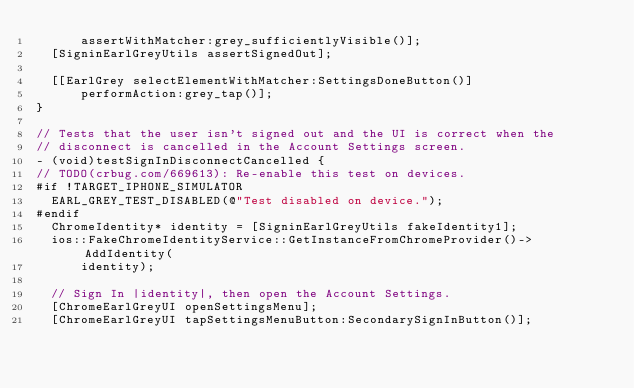Convert code to text. <code><loc_0><loc_0><loc_500><loc_500><_ObjectiveC_>      assertWithMatcher:grey_sufficientlyVisible()];
  [SigninEarlGreyUtils assertSignedOut];

  [[EarlGrey selectElementWithMatcher:SettingsDoneButton()]
      performAction:grey_tap()];
}

// Tests that the user isn't signed out and the UI is correct when the
// disconnect is cancelled in the Account Settings screen.
- (void)testSignInDisconnectCancelled {
// TODO(crbug.com/669613): Re-enable this test on devices.
#if !TARGET_IPHONE_SIMULATOR
  EARL_GREY_TEST_DISABLED(@"Test disabled on device.");
#endif
  ChromeIdentity* identity = [SigninEarlGreyUtils fakeIdentity1];
  ios::FakeChromeIdentityService::GetInstanceFromChromeProvider()->AddIdentity(
      identity);

  // Sign In |identity|, then open the Account Settings.
  [ChromeEarlGreyUI openSettingsMenu];
  [ChromeEarlGreyUI tapSettingsMenuButton:SecondarySignInButton()];</code> 